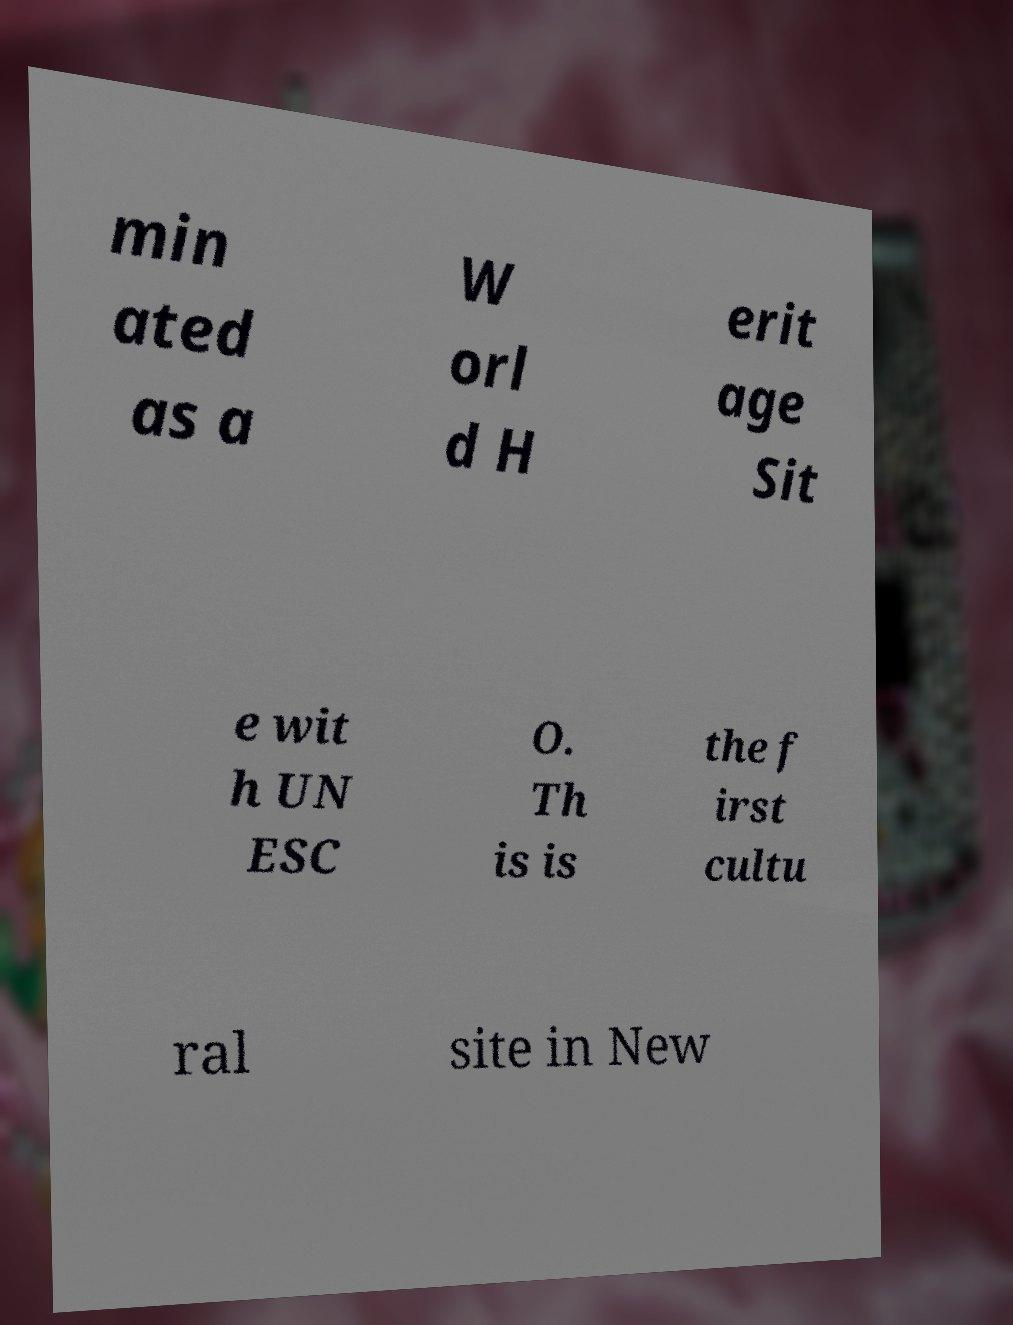I need the written content from this picture converted into text. Can you do that? min ated as a W orl d H erit age Sit e wit h UN ESC O. Th is is the f irst cultu ral site in New 